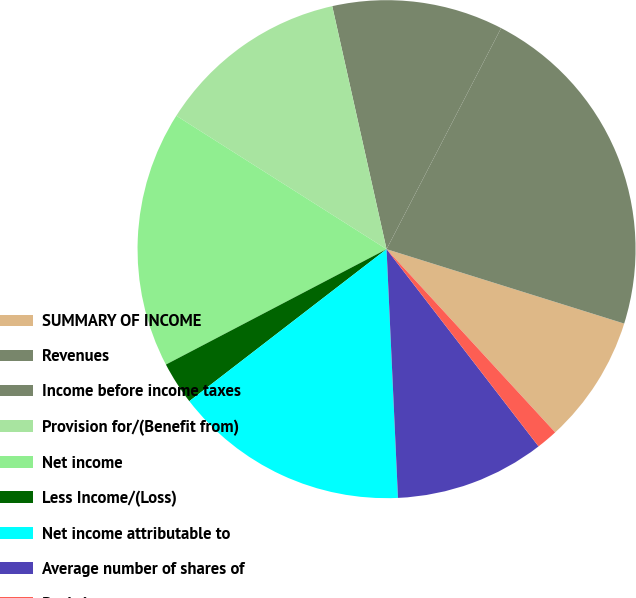<chart> <loc_0><loc_0><loc_500><loc_500><pie_chart><fcel>SUMMARY OF INCOME<fcel>Revenues<fcel>Income before income taxes<fcel>Provision for/(Benefit from)<fcel>Net income<fcel>Less Income/(Loss)<fcel>Net income attributable to<fcel>Average number of shares of<fcel>Basic income<fcel>Diluted income<nl><fcel>8.33%<fcel>22.22%<fcel>11.11%<fcel>12.5%<fcel>16.67%<fcel>2.78%<fcel>15.28%<fcel>9.72%<fcel>1.39%<fcel>0.0%<nl></chart> 